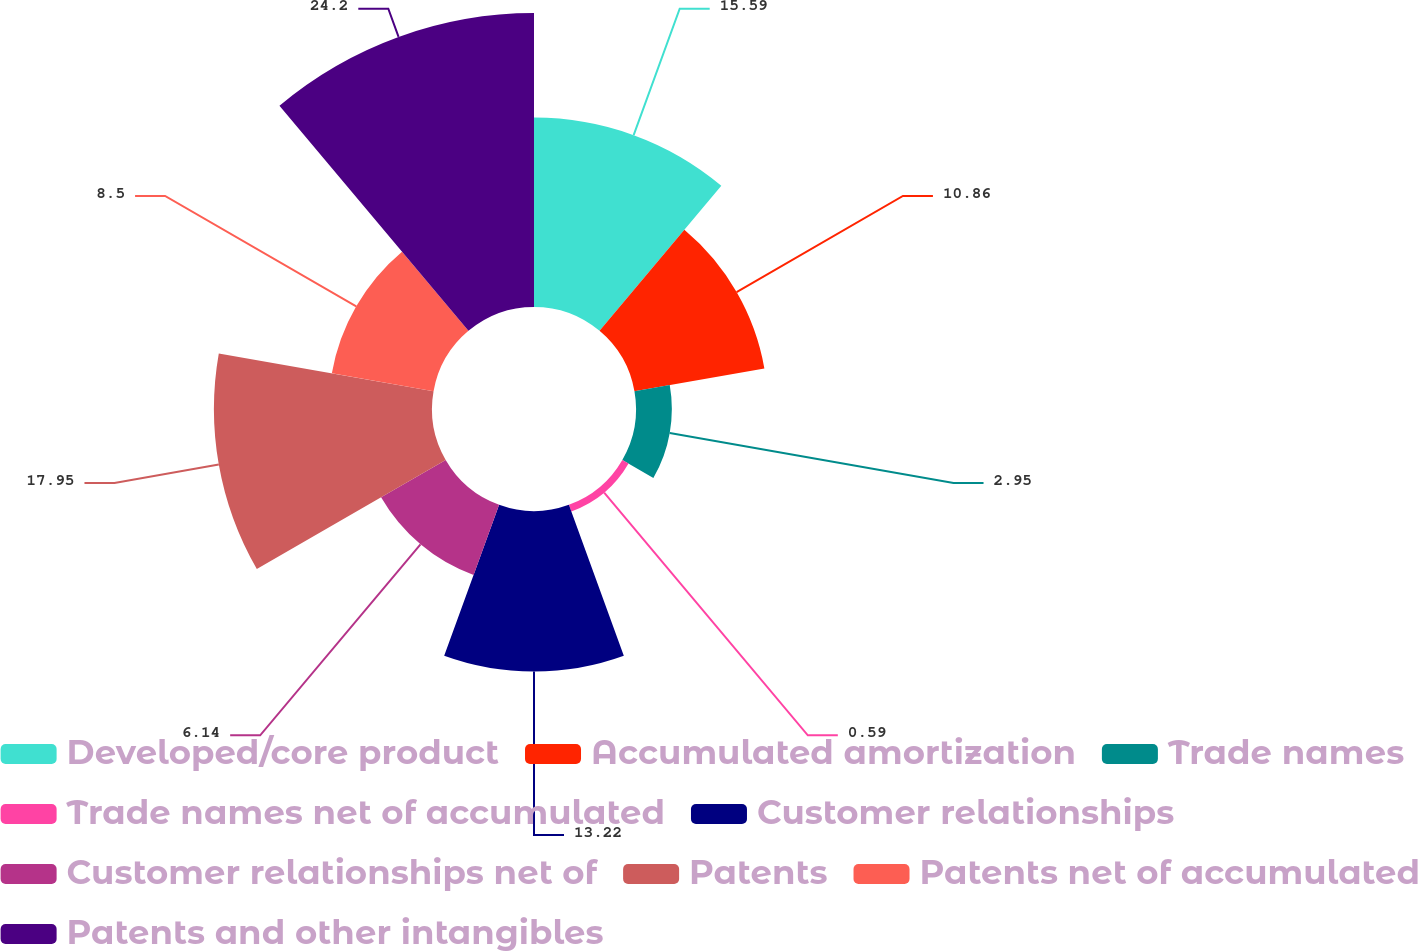Convert chart. <chart><loc_0><loc_0><loc_500><loc_500><pie_chart><fcel>Developed/core product<fcel>Accumulated amortization<fcel>Trade names<fcel>Trade names net of accumulated<fcel>Customer relationships<fcel>Customer relationships net of<fcel>Patents<fcel>Patents net of accumulated<fcel>Patents and other intangibles<nl><fcel>15.59%<fcel>10.86%<fcel>2.95%<fcel>0.59%<fcel>13.22%<fcel>6.14%<fcel>17.95%<fcel>8.5%<fcel>24.2%<nl></chart> 